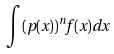<formula> <loc_0><loc_0><loc_500><loc_500>\int ( p ( x ) ) ^ { n } f ( x ) d x</formula> 